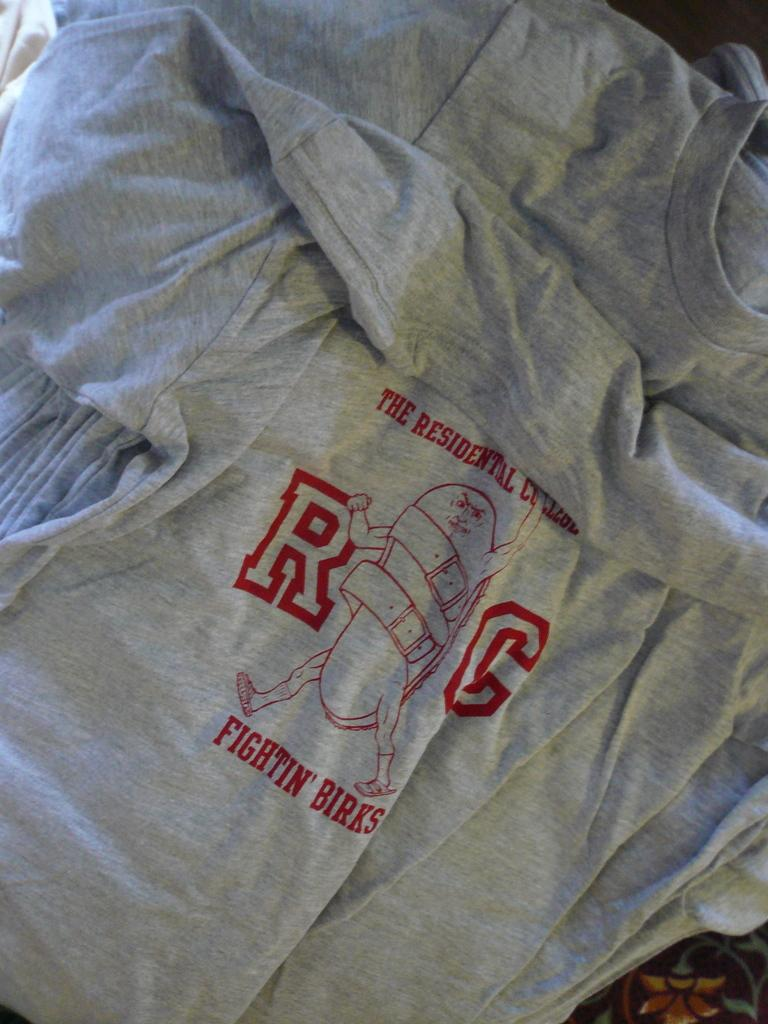Provide a one-sentence caption for the provided image. A grey shirt with red font that reads RG, Fightin' Birks. 